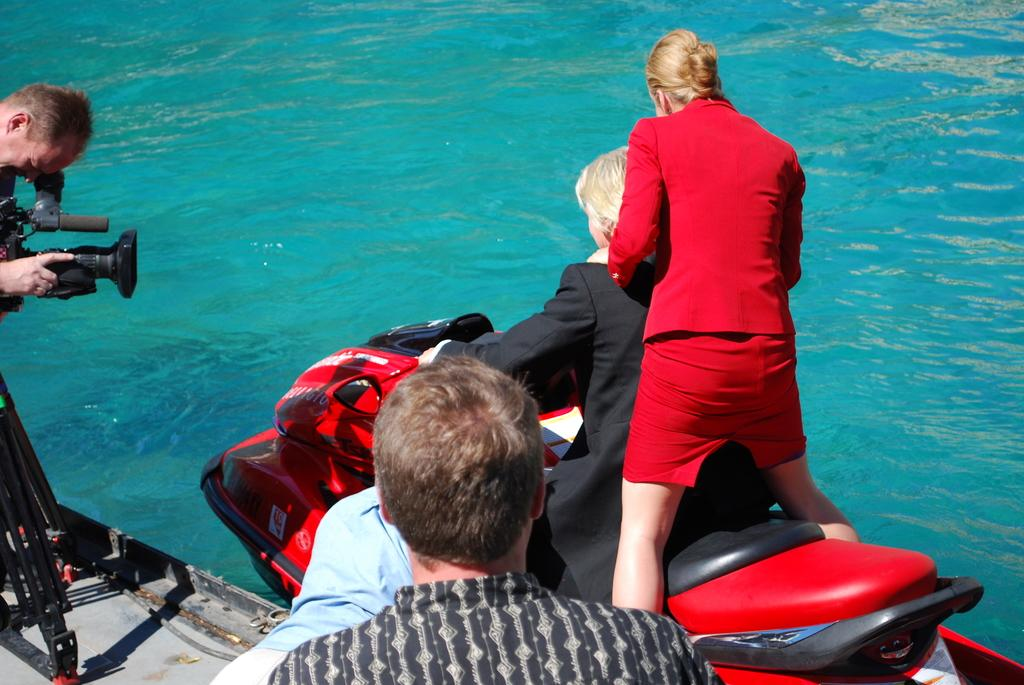What is happening in the foreground of the image? There are people in the foreground of the image. Can you describe the activity of one of the people in the image? One person is holding a camera. What can be seen in the background of the image? There are two people on a boat bike in the background of the image. Where is the boat bike located? The boat bike is on the water. What type of receipt is being held by the person on the boat bike? There is no receipt present in the image; the person on the boat bike is not holding anything. What thought is being expressed by the person holding the camera? The image does not provide any information about the thoughts of the person holding the camera. 